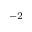Convert formula to latex. <formula><loc_0><loc_0><loc_500><loc_500>^ { - 2 }</formula> 